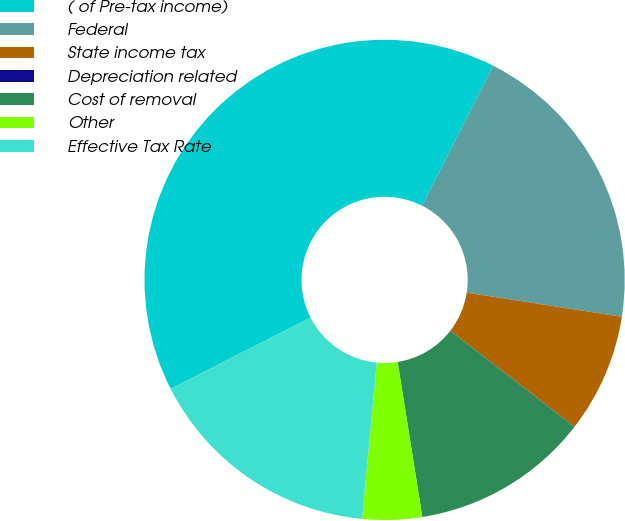Convert chart. <chart><loc_0><loc_0><loc_500><loc_500><pie_chart><fcel>( of Pre-tax income)<fcel>Federal<fcel>State income tax<fcel>Depreciation related<fcel>Cost of removal<fcel>Other<fcel>Effective Tax Rate<nl><fcel>39.96%<fcel>19.99%<fcel>8.01%<fcel>0.02%<fcel>12.0%<fcel>4.01%<fcel>16.0%<nl></chart> 